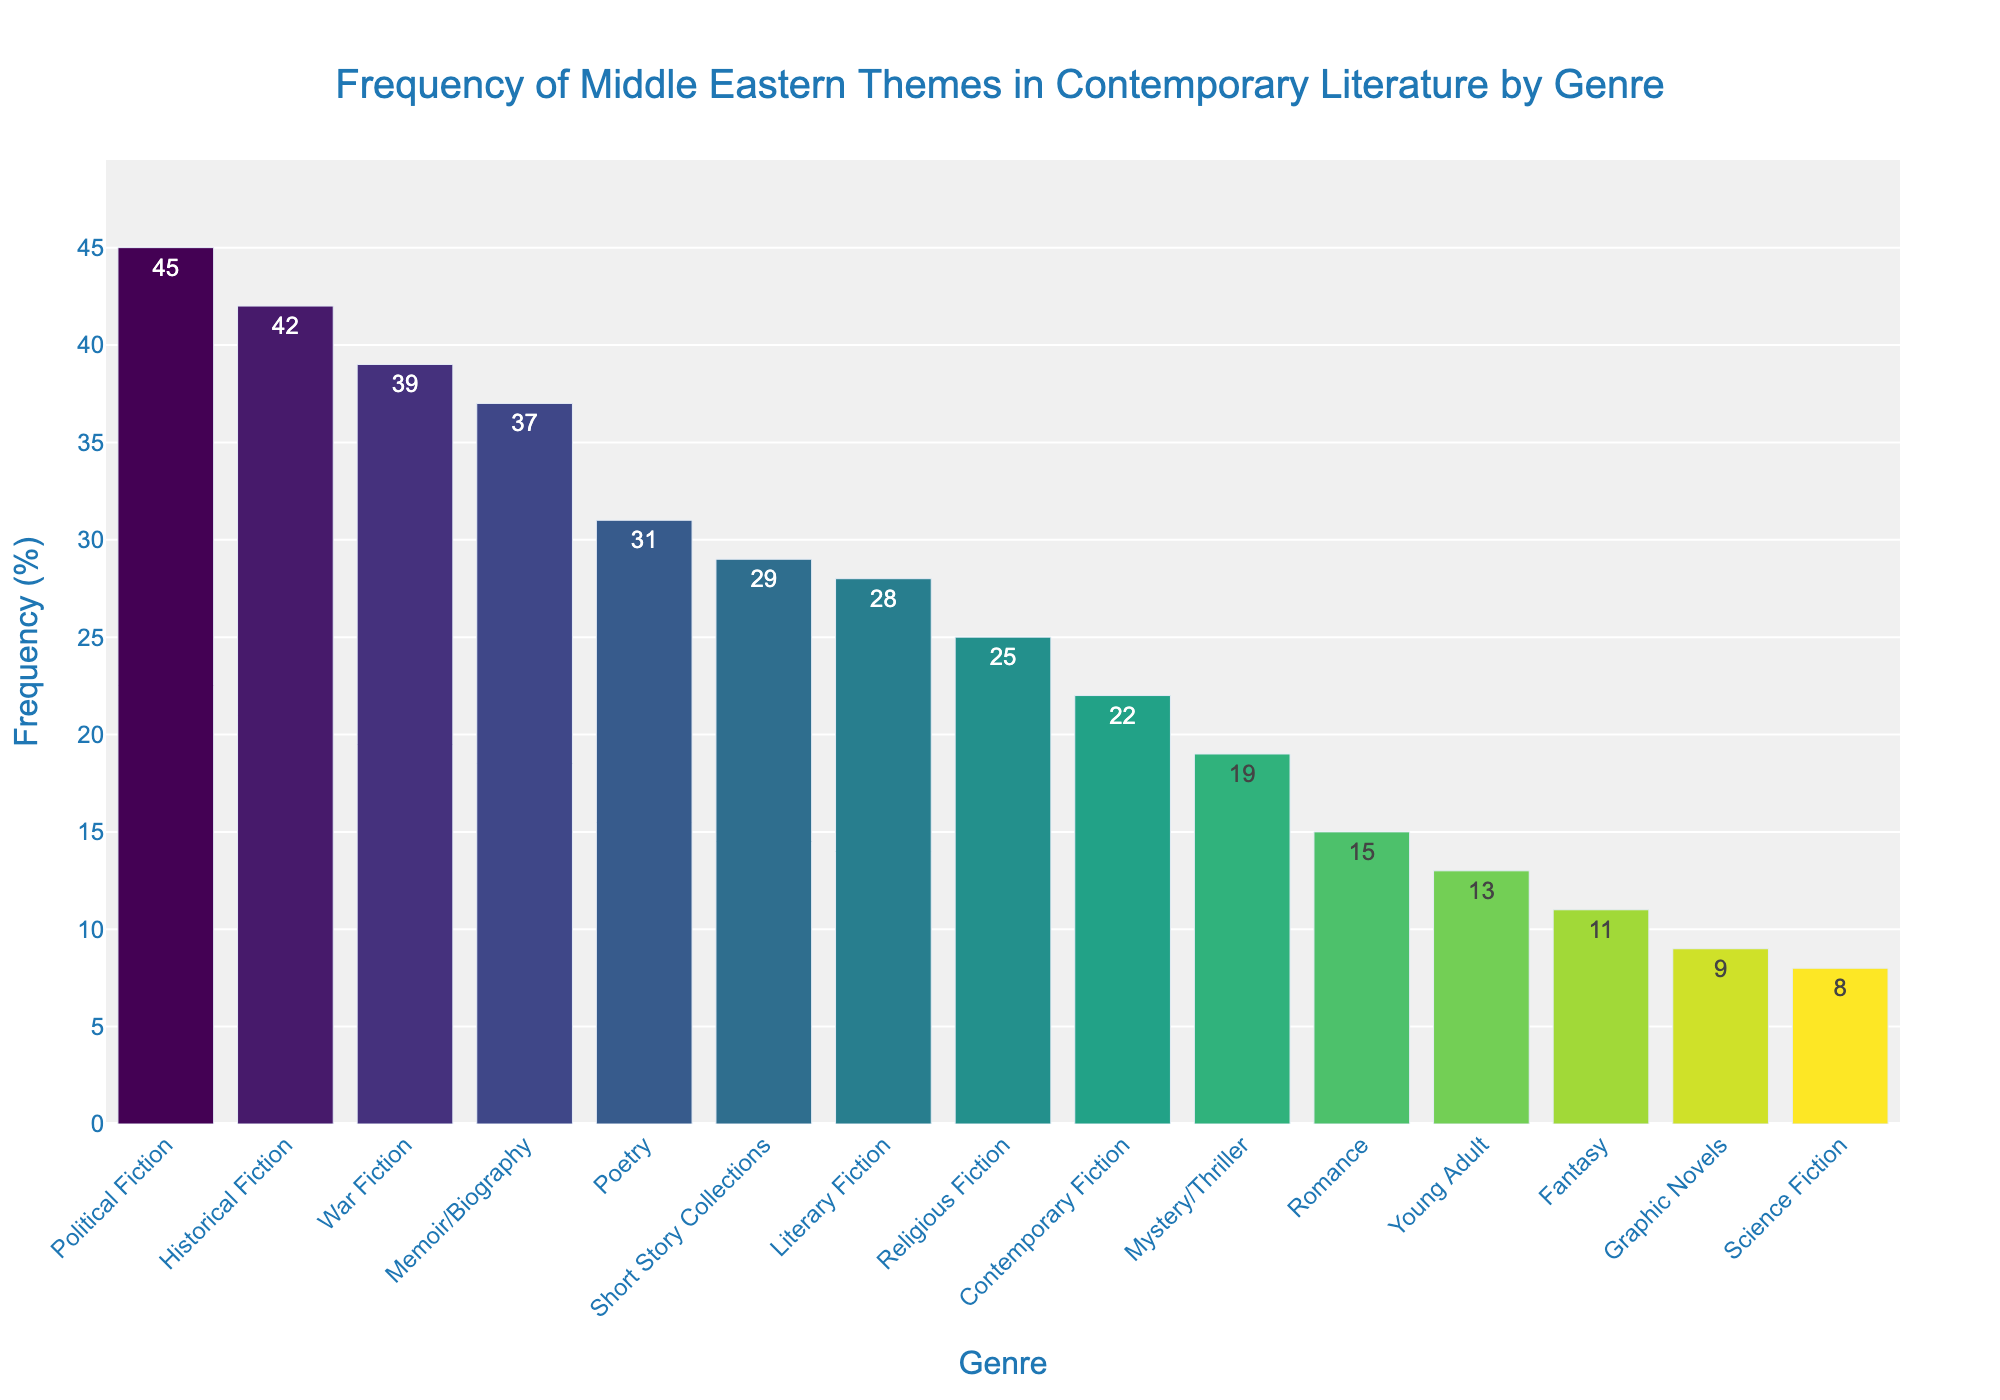What genre has the highest frequency of Middle Eastern themes? The genre with the highest frequency of Middle Eastern themes can be observed as having the tallest bar on the chart.
Answer: Political Fiction Which genre has a higher frequency of Middle Eastern themes, Historical Fiction or Fantasy? By comparing the height of the bars, you can see that the bar for Historical Fiction is taller than that of Fantasy.
Answer: Historical Fiction How much higher is the frequency of Middle Eastern themes in War Fiction compared to Contemporary Fiction? The frequency of Middle Eastern themes in War Fiction is 39%, and in Contemporary Fiction, it is 22%. The difference is calculated as 39% - 22% = 17%.
Answer: 17% What is the average frequency of Middle Eastern themes in Memoir/Biography, Poetry, and Short Story Collections? Adding up the frequencies of Middle Eastern themes in these genres: 37% (Memoir/Biography) + 31% (Poetry) + 29% (Short Story Collections) = 97%. Dividing by the number of genres (3) gives us an average of 97% / 3 = 32.33%.
Answer: 32.33% Is the frequency of Middle Eastern themes higher in Science Fiction or Religious Fiction? Comparing the bars, the frequency for Religious Fiction is 25%, while Science Fiction is 8%. Thus, Religious Fiction has a higher frequency.
Answer: Religious Fiction Which genres have a frequency of Middle Eastern themes below 20%? By observing the bars with heights below the 20% mark, these genres are Mystery/Thriller (19%), Romance (15%), Young Adult (13%), Graphic Novels (9%), and Science Fiction (8%).
Answer: Mystery/Thriller, Romance, Young Adult, Graphic Novels, Science Fiction If you combine the frequencies of Literary Fiction and Poetry, what is the total? The frequencies are 28% for Literary Fiction and 31% for Poetry. Adding them together gives 28% + 31% = 59%.
Answer: 59% What is the frequency range of Middle Eastern themes across all genres? The frequency range can be determined by subtracting the smallest frequency (Science Fiction, 8%) from the largest frequency (Political Fiction, 45%). The range is 45% - 8% = 37%.
Answer: 37% What is the median frequency of Middle Eastern themes among all genres? First, arrange the frequencies in ascending order: 8, 9, 11, 13, 15, 19, 22, 25, 28, 29, 31, 37, 39, 42, 45. The middle value (8th value) in this ordered list is 25%.
Answer: 25% Between Mystery/Thriller and Romance, which genre has a lower frequency of Middle Eastern themes and by how much? The frequency for Mystery/Thriller is 19% and for Romance is 15%. Romance has a lower frequency, and the difference is 19% - 15% = 4%.
Answer: Romance by 4% 